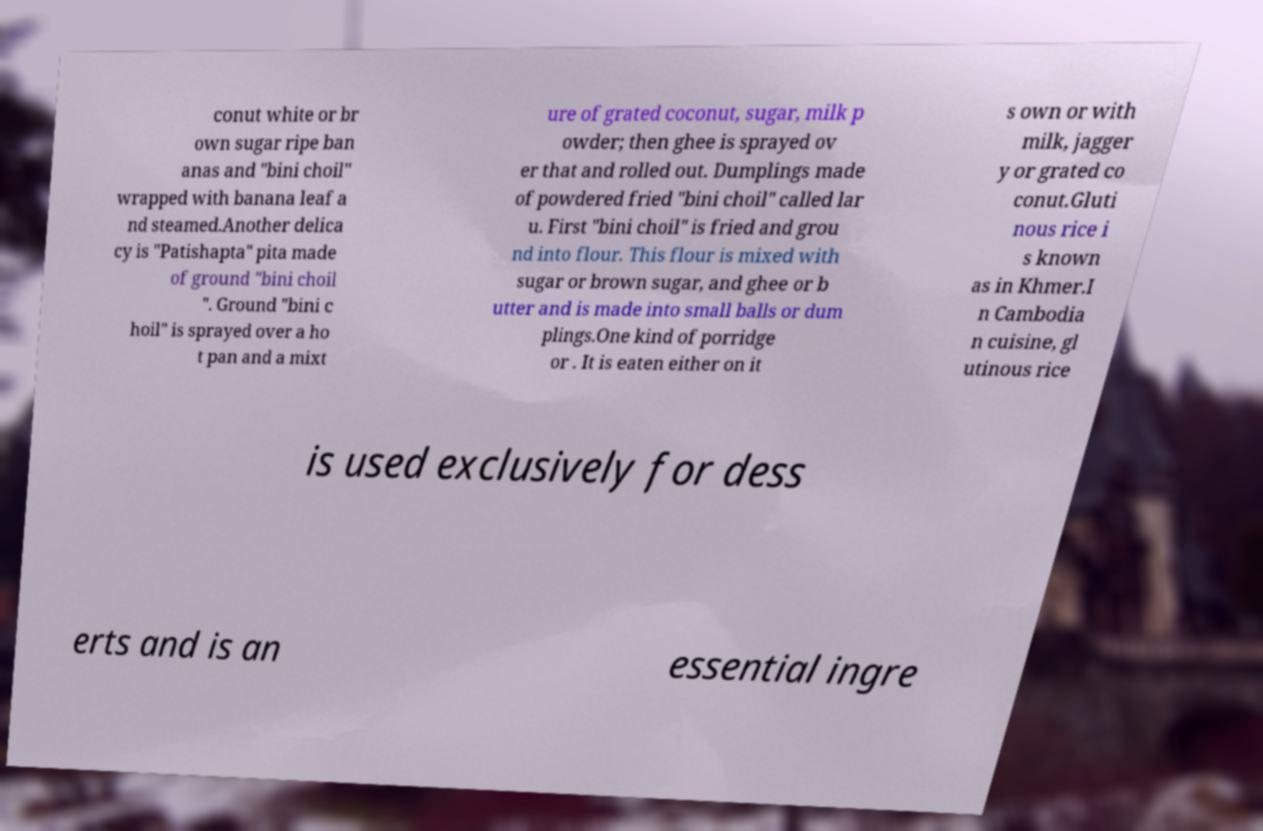For documentation purposes, I need the text within this image transcribed. Could you provide that? conut white or br own sugar ripe ban anas and "bini choil" wrapped with banana leaf a nd steamed.Another delica cy is "Patishapta" pita made of ground "bini choil ". Ground "bini c hoil" is sprayed over a ho t pan and a mixt ure of grated coconut, sugar, milk p owder; then ghee is sprayed ov er that and rolled out. Dumplings made of powdered fried "bini choil" called lar u. First "bini choil" is fried and grou nd into flour. This flour is mixed with sugar or brown sugar, and ghee or b utter and is made into small balls or dum plings.One kind of porridge or . It is eaten either on it s own or with milk, jagger y or grated co conut.Gluti nous rice i s known as in Khmer.I n Cambodia n cuisine, gl utinous rice is used exclusively for dess erts and is an essential ingre 